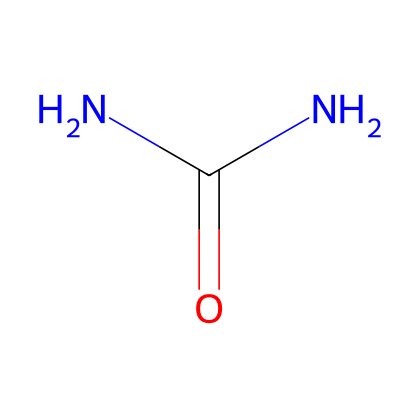What is the total number of nitrogen atoms in this chemical? The chemical structure contains two nitrogen (N) atoms, as seen from the formula NC(=O)N.
Answer: two How many carbon atoms are present in this chemical? The chemical has one carbon (C) atom as represented in the structure NC(=O)N.
Answer: one What type of functional group is present in this chemical? The presence of the carbonyl group (C=O) indicates that this chemical contains an amide functional group, given the context of the surrounding nitrogen atoms.
Answer: amide Are there any geometric isomers possible for this chemical? The presence of two identical nitrogen atoms (and no different groups attached to the carbon) means that this chemical does not have any geometric isomers due to lack of restricted rotation around the C-N bond.
Answer: no What is the oxidation state of the carbon in this chemical? The carbon atom is double-bonded to the oxygen and single-bonded to two nitrogen atoms, giving it an oxidation state of +1. The calculation is based on carbon usually being in the 0 oxidation state and adjusting for the bonds.
Answer: one What is the bioavailability of this amide when applied as fertilizer? As an amide, the chemical typically has high bioavailability because it can readily undergo hydrolysis in soil, making nitrogen available for plant uptake.
Answer: high 